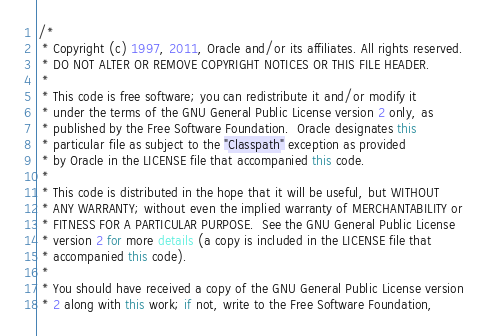Convert code to text. <code><loc_0><loc_0><loc_500><loc_500><_Java_>/*
 * Copyright (c) 1997, 2011, Oracle and/or its affiliates. All rights reserved.
 * DO NOT ALTER OR REMOVE COPYRIGHT NOTICES OR THIS FILE HEADER.
 *
 * This code is free software; you can redistribute it and/or modify it
 * under the terms of the GNU General Public License version 2 only, as
 * published by the Free Software Foundation.  Oracle designates this
 * particular file as subject to the "Classpath" exception as provided
 * by Oracle in the LICENSE file that accompanied this code.
 *
 * This code is distributed in the hope that it will be useful, but WITHOUT
 * ANY WARRANTY; without even the implied warranty of MERCHANTABILITY or
 * FITNESS FOR A PARTICULAR PURPOSE.  See the GNU General Public License
 * version 2 for more details (a copy is included in the LICENSE file that
 * accompanied this code).
 *
 * You should have received a copy of the GNU General Public License version
 * 2 along with this work; if not, write to the Free Software Foundation,</code> 